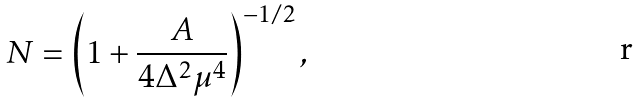<formula> <loc_0><loc_0><loc_500><loc_500>N = \left ( 1 + \frac { A } { 4 \Delta ^ { 2 } \mu ^ { 4 } } \right ) ^ { - 1 / 2 } ,</formula> 